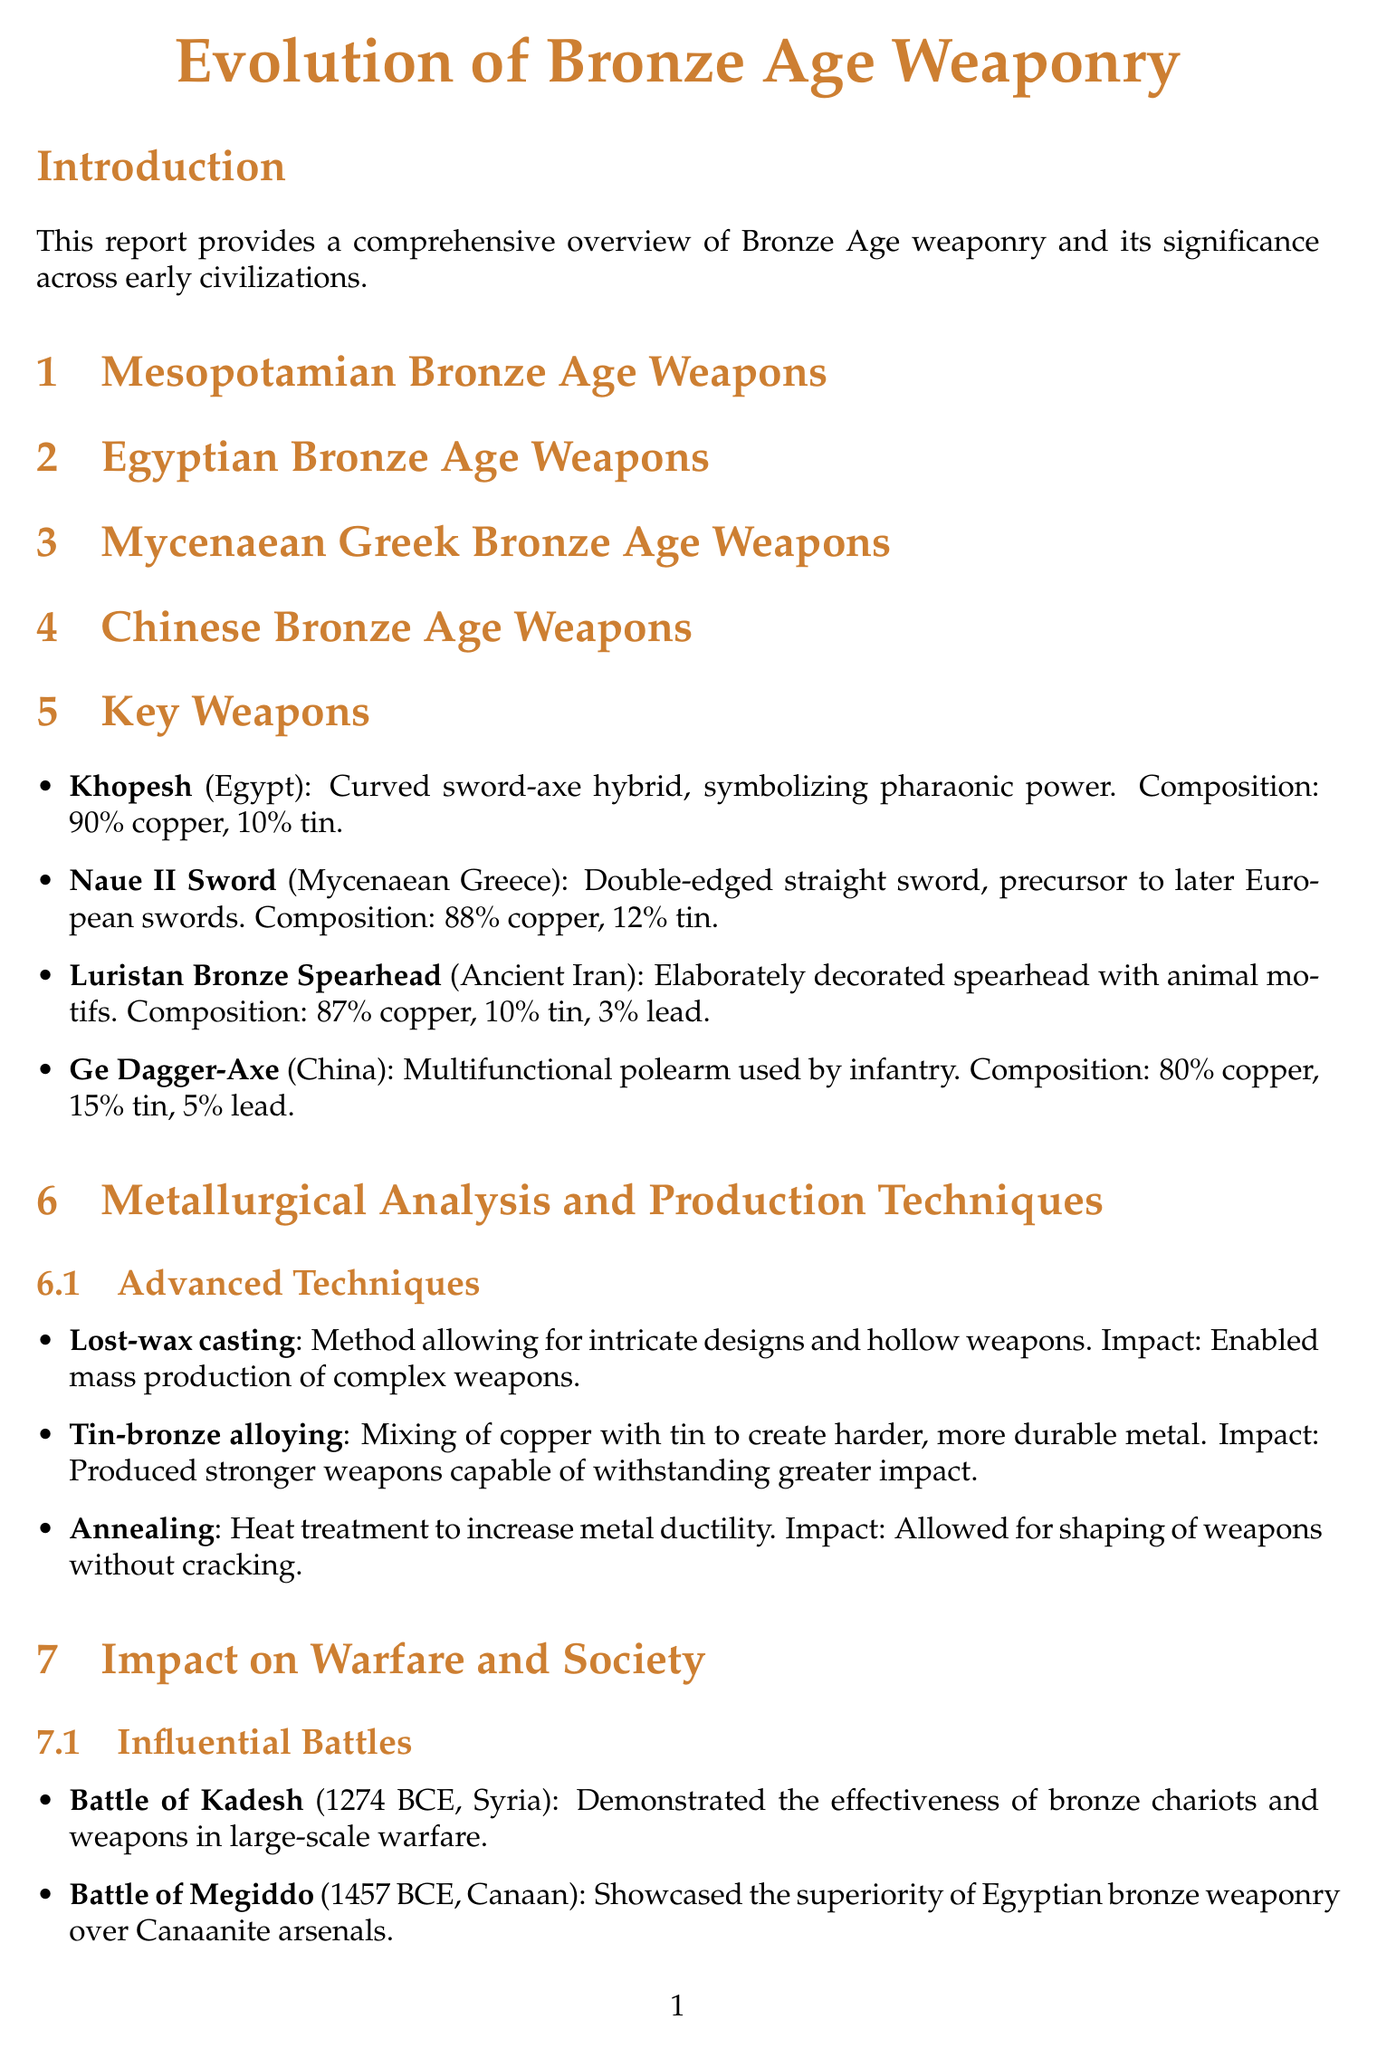What is the title of the report? The title of the report, as indicated in the document, is "Evolution of Bronze Age Weaponry".
Answer: Evolution of Bronze Age Weaponry Who is affiliated with the University of Cambridge? The document lists Dr. Harriet Whitehead as the expert associated with the University of Cambridge.
Answer: Dr. Harriet Whitehead What was one of the key advancements in bronze weapon production? The document mentions several advancements, including lost-wax casting, tin-bronze alloying, and annealing, which all contributed to improved weapon design.
Answer: Lost-wax casting What is the material composition of the Khopesh? The Khopesh is comprised of 90% copper and 10% tin according to the document.
Answer: 90% copper, 10% tin In which battle did bronze chariots notably demonstrate their effectiveness? The Battle of Kadesh showcased the effectiveness of bronze chariots in warfare according to the report.
Answer: Battle of Kadesh Where was the Nebra sky disk discovered? The document states that the Nebra sky disk was discovered in Germany.
Answer: Germany What kind of warriors primarily used the Ge Dagger-Axe? The Ge Dagger-Axe was primarily used by infantry, as noted in its description.
Answer: Infantry What significant archaeological site is located in Israel? The report cites Nahal Mishmar as a significant archaeological site in Israel.
Answer: Nahal Mishmar 